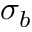<formula> <loc_0><loc_0><loc_500><loc_500>\sigma _ { b }</formula> 